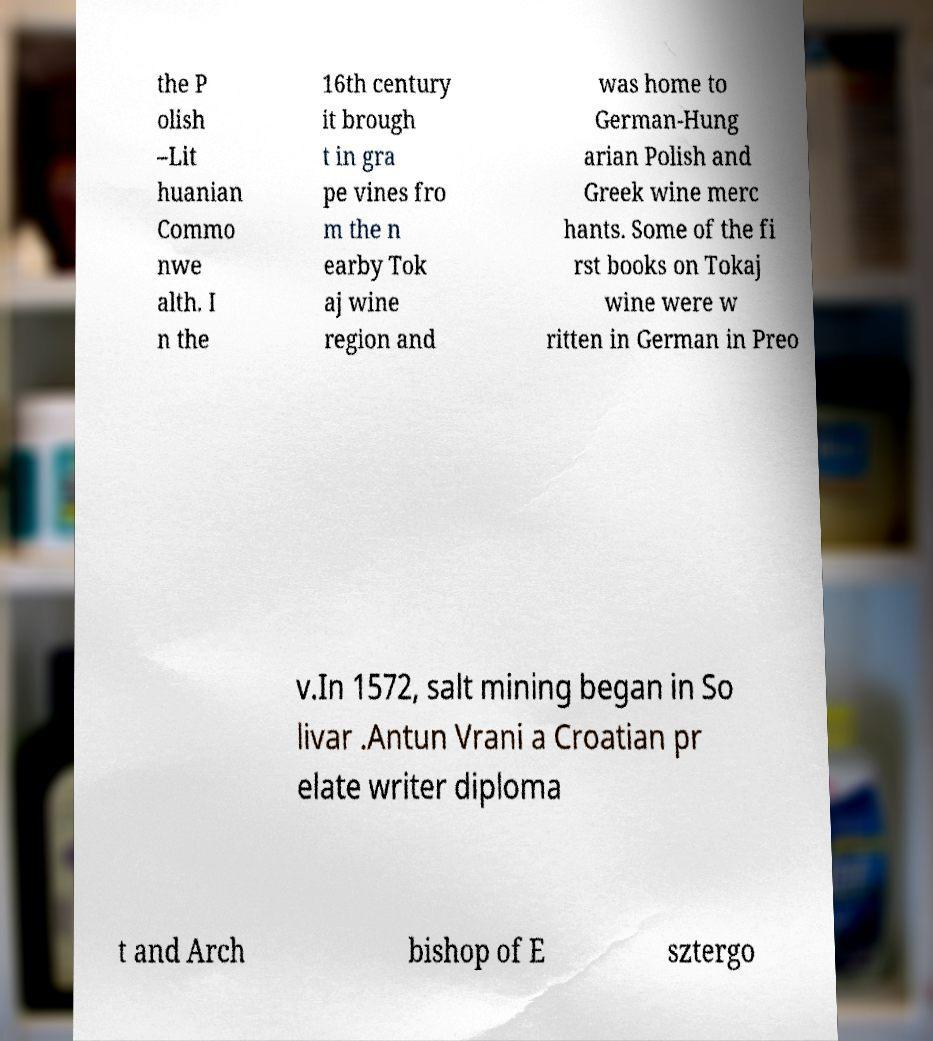Please identify and transcribe the text found in this image. the P olish –Lit huanian Commo nwe alth. I n the 16th century it brough t in gra pe vines fro m the n earby Tok aj wine region and was home to German-Hung arian Polish and Greek wine merc hants. Some of the fi rst books on Tokaj wine were w ritten in German in Preo v.In 1572, salt mining began in So livar .Antun Vrani a Croatian pr elate writer diploma t and Arch bishop of E sztergo 